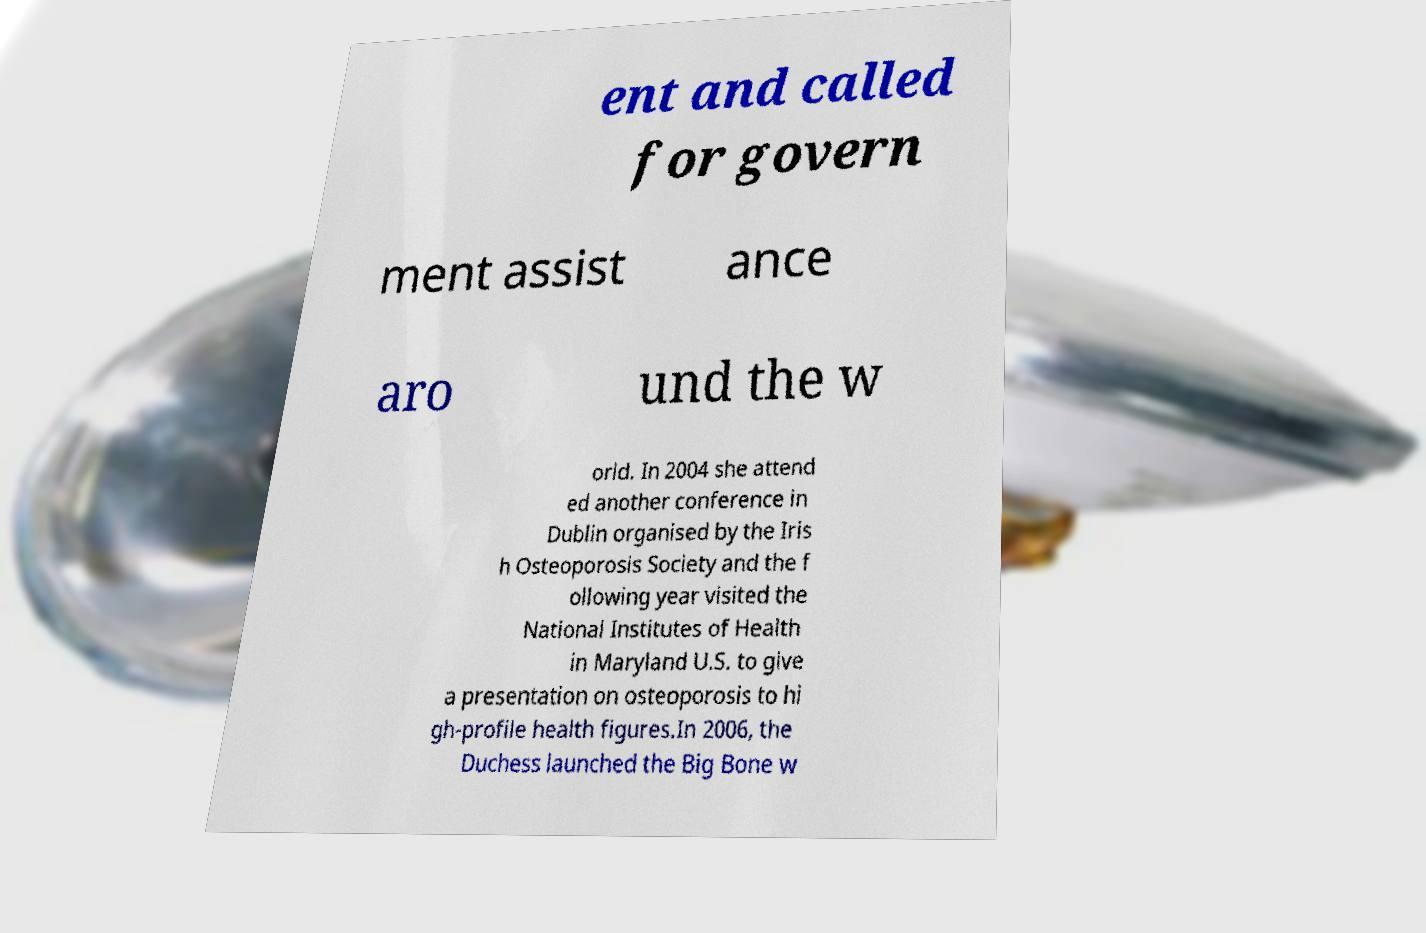Please read and relay the text visible in this image. What does it say? ent and called for govern ment assist ance aro und the w orld. In 2004 she attend ed another conference in Dublin organised by the Iris h Osteoporosis Society and the f ollowing year visited the National Institutes of Health in Maryland U.S. to give a presentation on osteoporosis to hi gh-profile health figures.In 2006, the Duchess launched the Big Bone w 